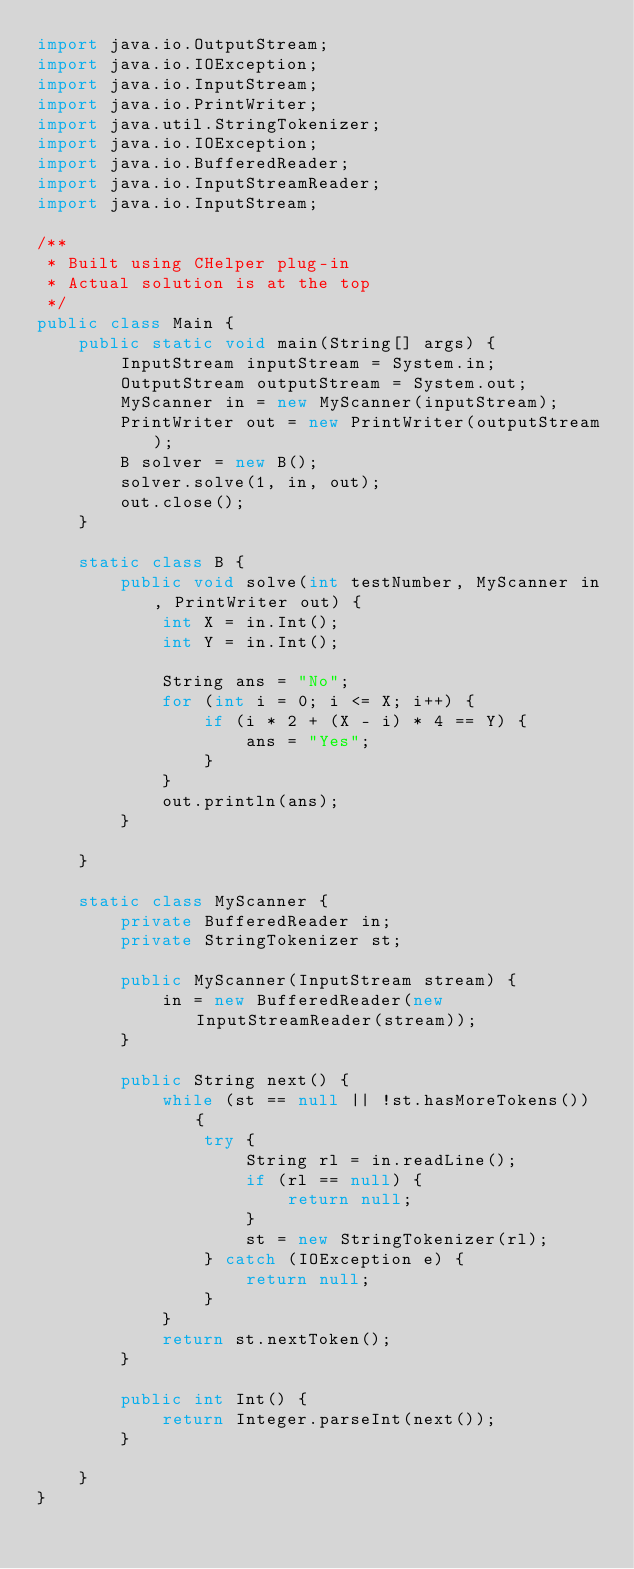<code> <loc_0><loc_0><loc_500><loc_500><_Java_>import java.io.OutputStream;
import java.io.IOException;
import java.io.InputStream;
import java.io.PrintWriter;
import java.util.StringTokenizer;
import java.io.IOException;
import java.io.BufferedReader;
import java.io.InputStreamReader;
import java.io.InputStream;

/**
 * Built using CHelper plug-in
 * Actual solution is at the top
 */
public class Main {
    public static void main(String[] args) {
        InputStream inputStream = System.in;
        OutputStream outputStream = System.out;
        MyScanner in = new MyScanner(inputStream);
        PrintWriter out = new PrintWriter(outputStream);
        B solver = new B();
        solver.solve(1, in, out);
        out.close();
    }

    static class B {
        public void solve(int testNumber, MyScanner in, PrintWriter out) {
            int X = in.Int();
            int Y = in.Int();

            String ans = "No";
            for (int i = 0; i <= X; i++) {
                if (i * 2 + (X - i) * 4 == Y) {
                    ans = "Yes";
                }
            }
            out.println(ans);
        }

    }

    static class MyScanner {
        private BufferedReader in;
        private StringTokenizer st;

        public MyScanner(InputStream stream) {
            in = new BufferedReader(new InputStreamReader(stream));
        }

        public String next() {
            while (st == null || !st.hasMoreTokens()) {
                try {
                    String rl = in.readLine();
                    if (rl == null) {
                        return null;
                    }
                    st = new StringTokenizer(rl);
                } catch (IOException e) {
                    return null;
                }
            }
            return st.nextToken();
        }

        public int Int() {
            return Integer.parseInt(next());
        }

    }
}

</code> 